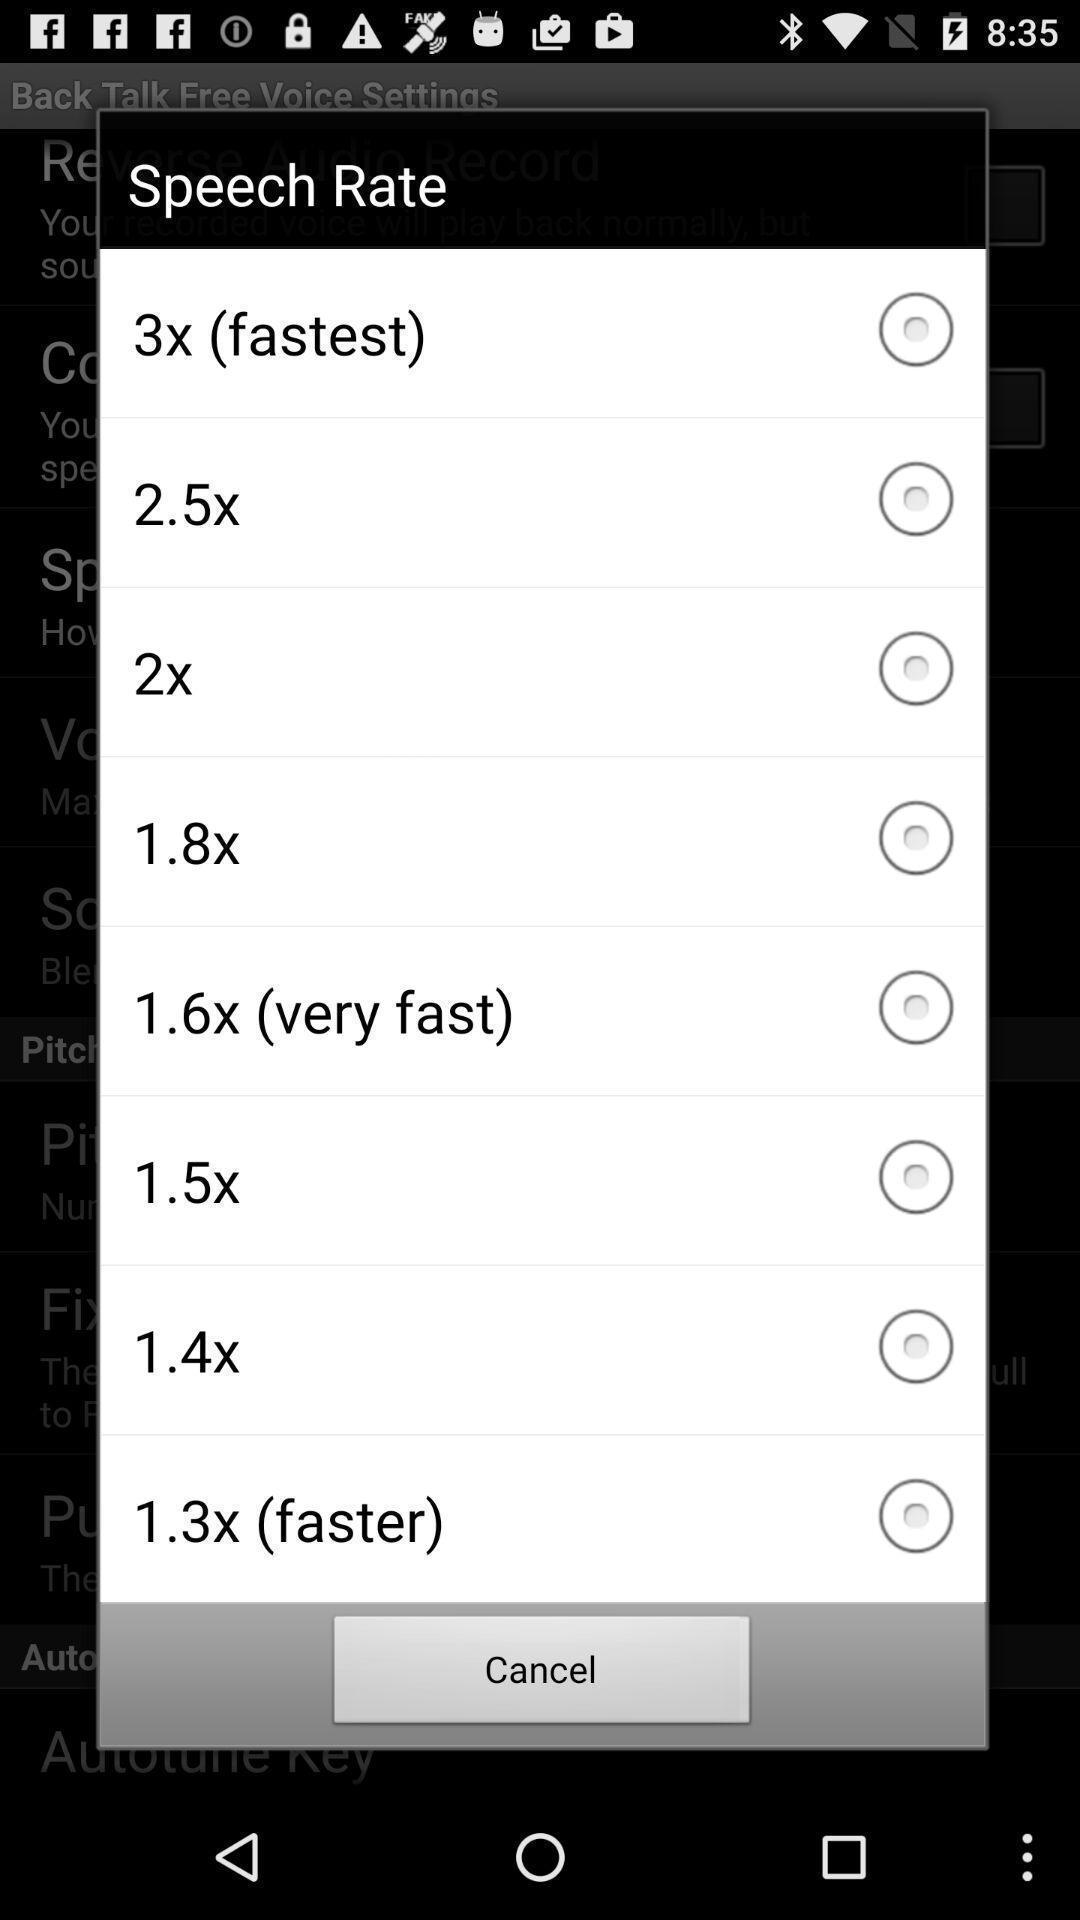Give me a summary of this screen capture. Pop-up with list of options for speech speed rate. 